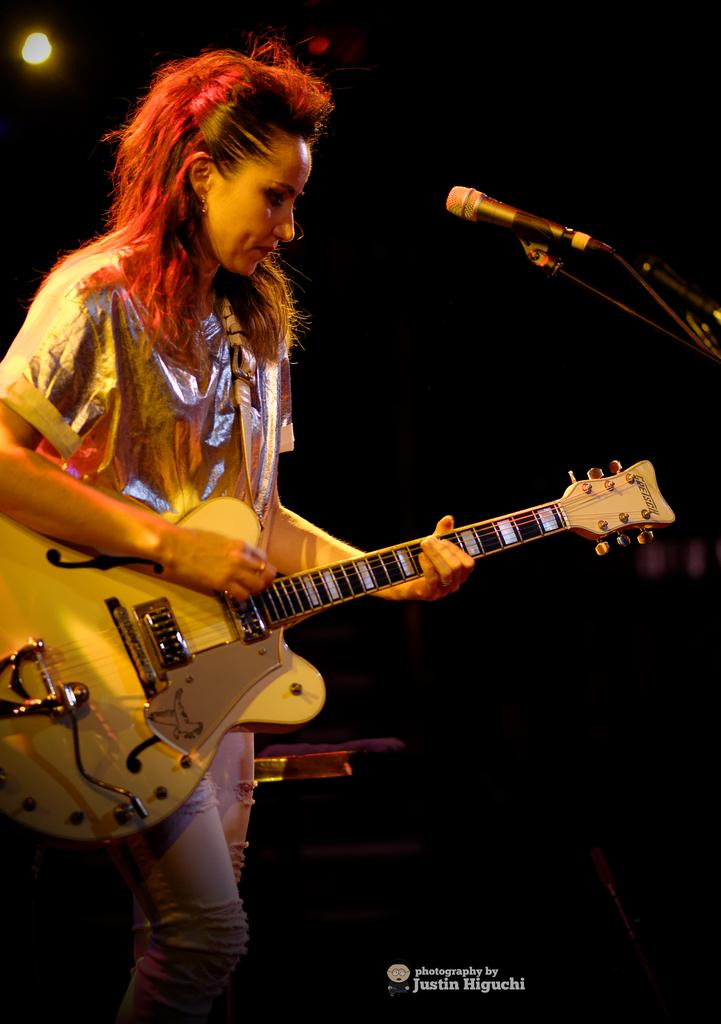Who is the main subject in the image? There is a woman in the image. What is the woman doing in the image? The woman is playing a guitar and is in front of a microphone. What is the woman wearing in the image? The woman is wearing a silver-colored t-shirt. What additional feature can be seen in the image? There is a focusing light visible in the image. What type of flowers can be seen in the image? There are no flowers present in the image. What kind of horn is being played by the woman in the image? The woman is playing a guitar, not a horn, in the image. 